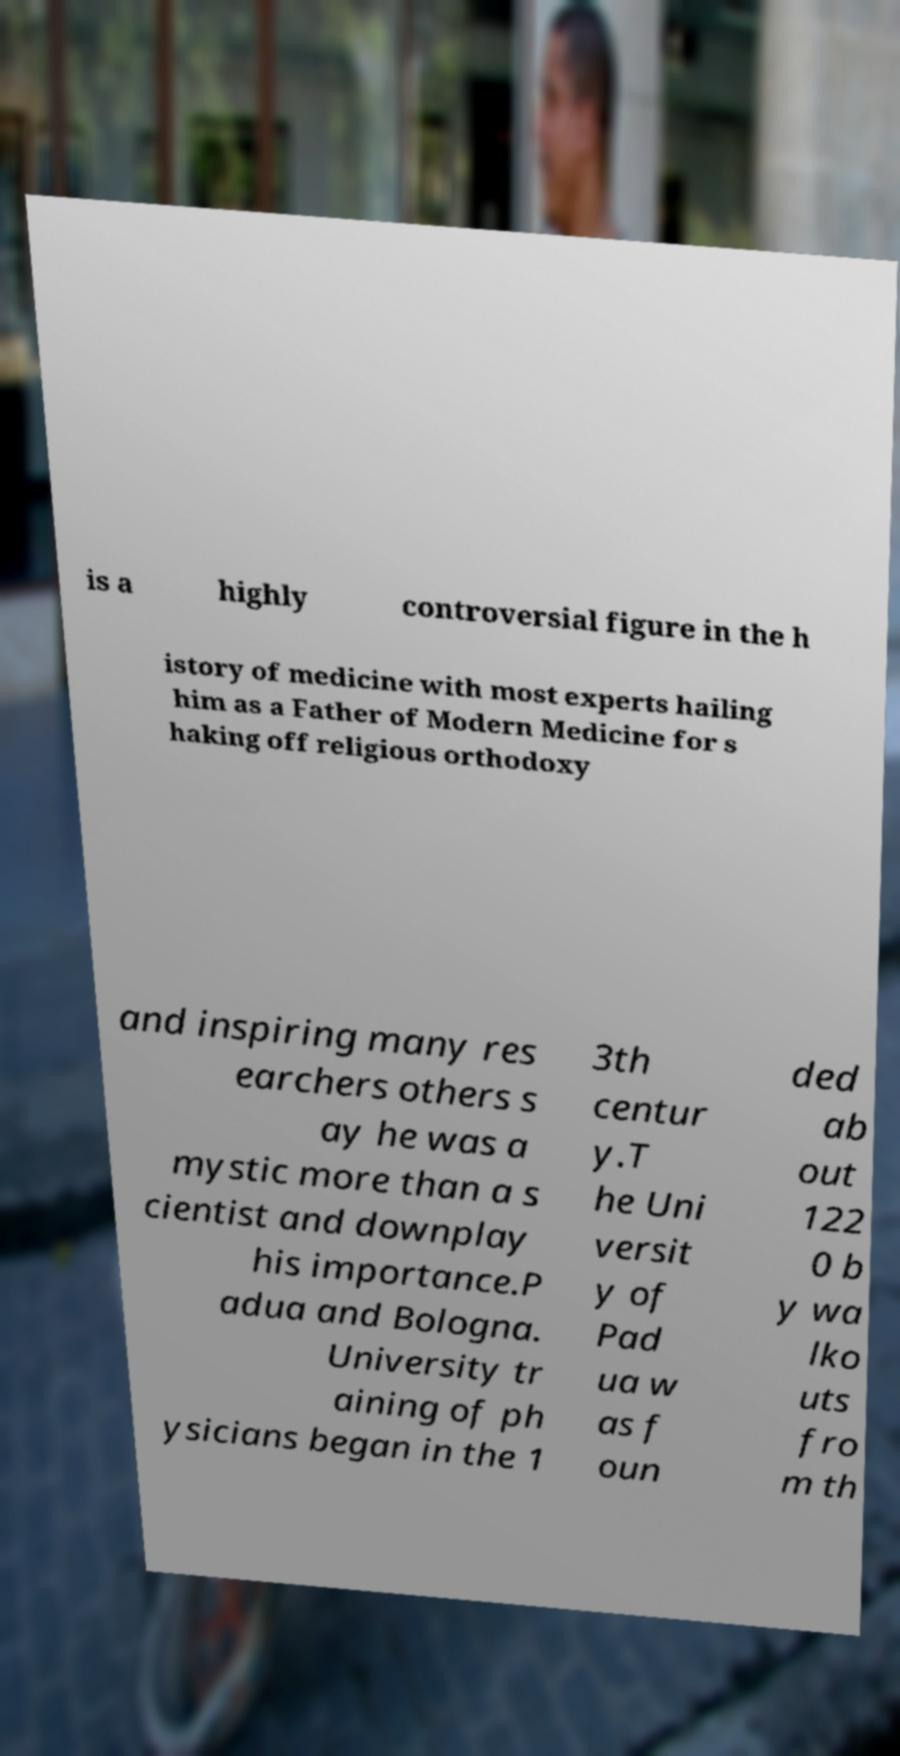What messages or text are displayed in this image? I need them in a readable, typed format. is a highly controversial figure in the h istory of medicine with most experts hailing him as a Father of Modern Medicine for s haking off religious orthodoxy and inspiring many res earchers others s ay he was a mystic more than a s cientist and downplay his importance.P adua and Bologna. University tr aining of ph ysicians began in the 1 3th centur y.T he Uni versit y of Pad ua w as f oun ded ab out 122 0 b y wa lko uts fro m th 